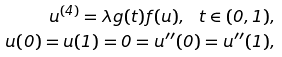<formula> <loc_0><loc_0><loc_500><loc_500>u ^ { ( 4 ) } = \lambda g ( t ) f ( u ) , \ t \in ( 0 , 1 ) , \\ u ( 0 ) = u ( 1 ) = 0 = u ^ { \prime \prime } ( 0 ) = u ^ { \prime \prime } ( 1 ) ,</formula> 